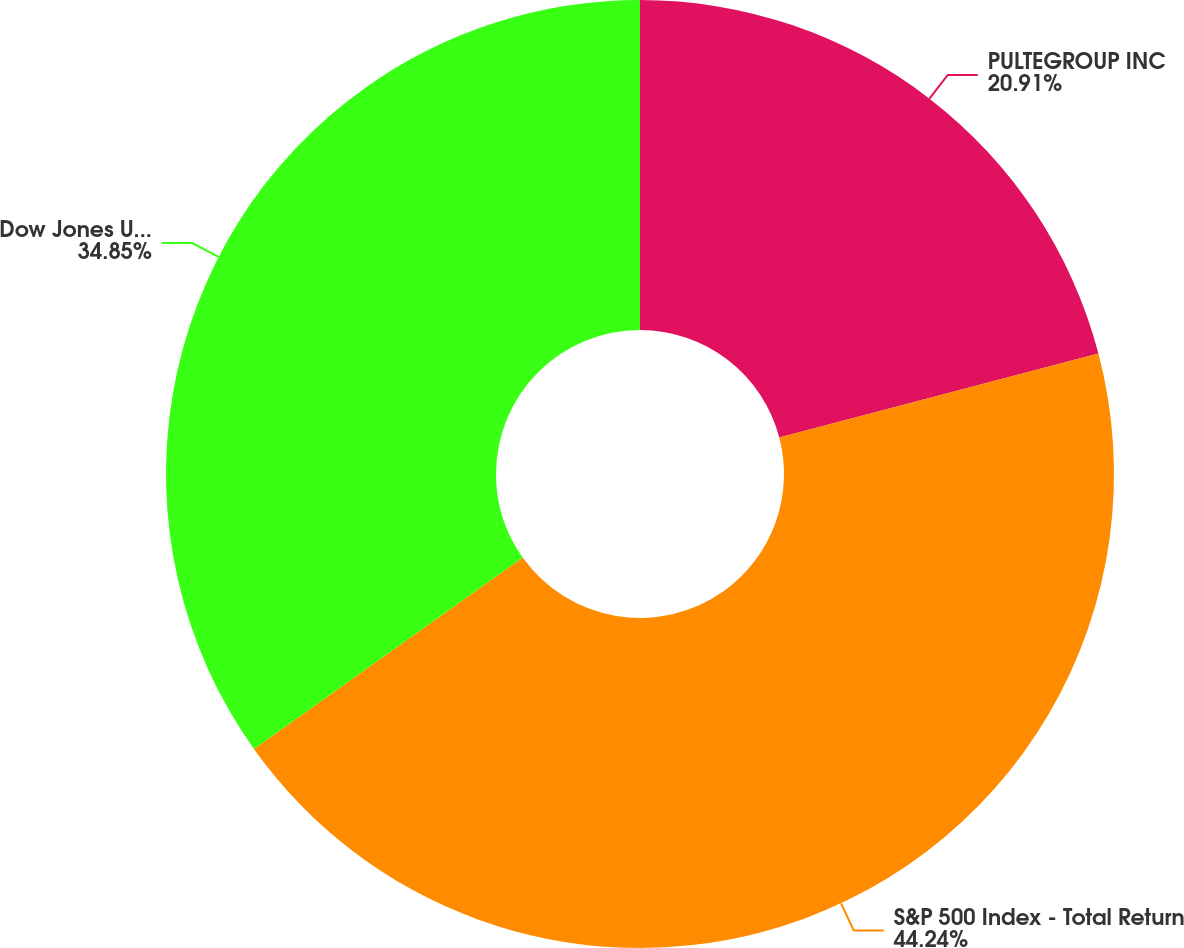<chart> <loc_0><loc_0><loc_500><loc_500><pie_chart><fcel>PULTEGROUP INC<fcel>S&P 500 Index - Total Return<fcel>Dow Jones US Select Home<nl><fcel>20.91%<fcel>44.24%<fcel>34.85%<nl></chart> 